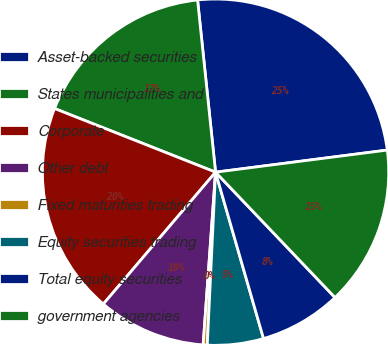Convert chart to OTSL. <chart><loc_0><loc_0><loc_500><loc_500><pie_chart><fcel>Asset-backed securities<fcel>States municipalities and<fcel>Corporate<fcel>Other debt<fcel>Fixed maturities trading<fcel>Equity securities trading<fcel>Total equity securities<fcel>government agencies<nl><fcel>24.62%<fcel>17.35%<fcel>19.77%<fcel>10.08%<fcel>0.38%<fcel>5.23%<fcel>7.65%<fcel>14.92%<nl></chart> 